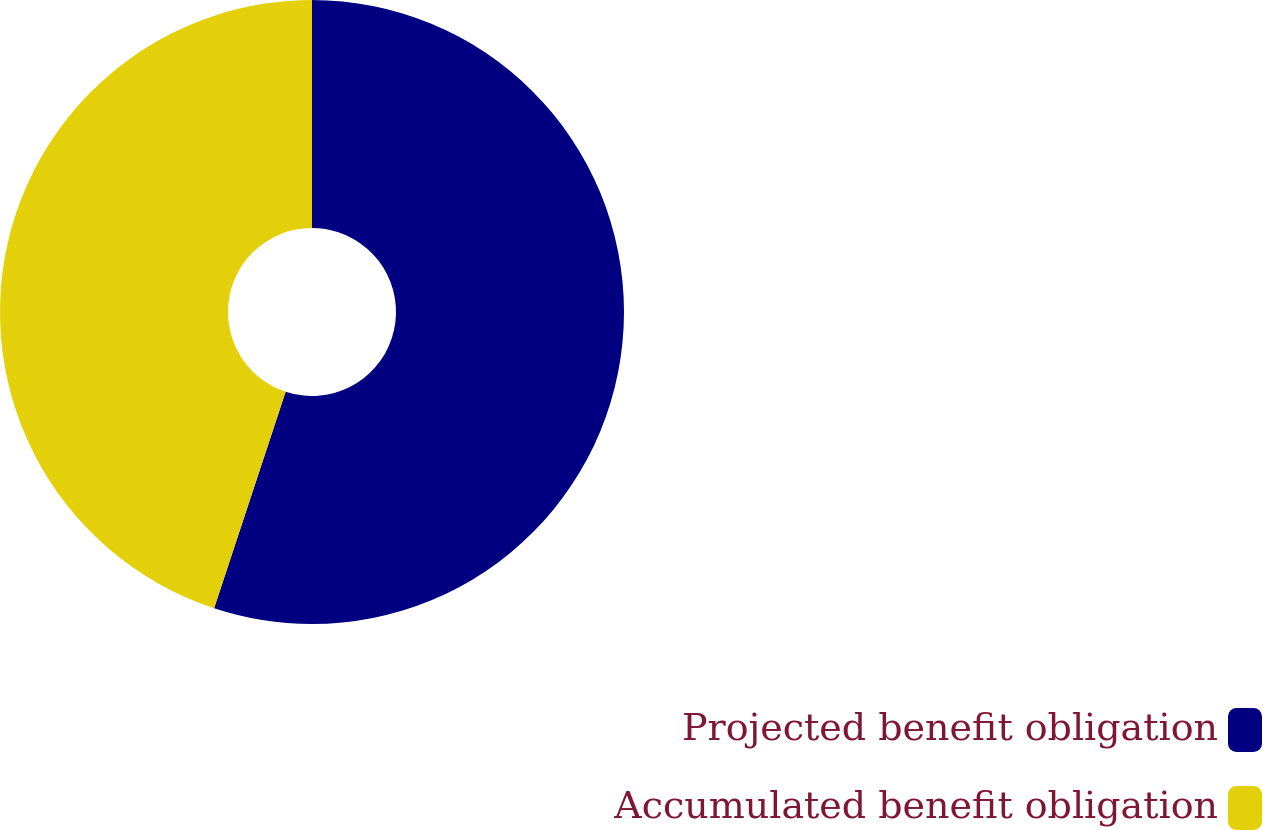<chart> <loc_0><loc_0><loc_500><loc_500><pie_chart><fcel>Projected benefit obligation<fcel>Accumulated benefit obligation<nl><fcel>55.08%<fcel>44.92%<nl></chart> 